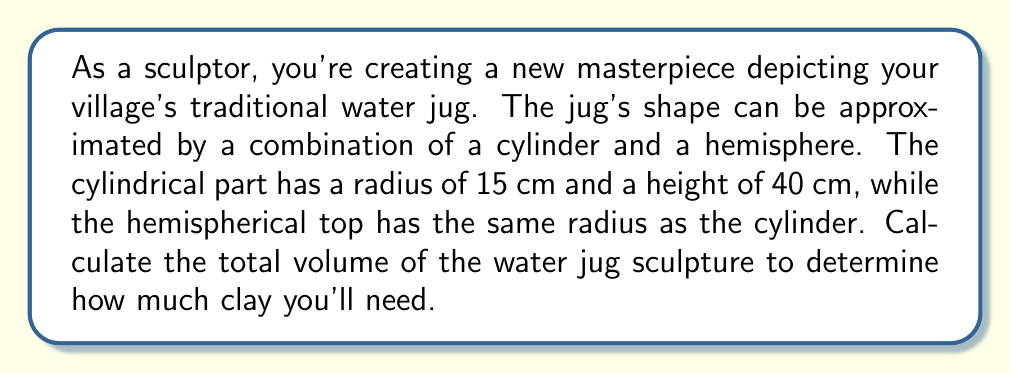Could you help me with this problem? To solve this problem, we need to calculate the volumes of the cylinder and hemisphere separately, then add them together.

1. Volume of the cylinder:
   The formula for the volume of a cylinder is $V_{cylinder} = \pi r^2 h$
   Where $r$ is the radius and $h$ is the height.
   
   $$V_{cylinder} = \pi (15\text{ cm})^2 (40\text{ cm}) = 28,274.33\text{ cm}^3$$

2. Volume of the hemisphere:
   The formula for the volume of a hemisphere is $V_{hemisphere} = \frac{2}{3}\pi r^3$
   
   $$V_{hemisphere} = \frac{2}{3}\pi (15\text{ cm})^3 = 7,068.58\text{ cm}^3$$

3. Total volume:
   Add the volumes of the cylinder and hemisphere:
   
   $$V_{total} = V_{cylinder} + V_{hemisphere}$$
   $$V_{total} = 28,274.33\text{ cm}^3 + 7,068.58\text{ cm}^3 = 35,342.91\text{ cm}^3$$

[asy]
import three;

size(200);
currentprojection=perspective(6,3,2);

// Draw cylinder
draw(surface(cylinder((0,0,0),15,40)),paleblue);

// Draw hemisphere
draw(surface(hemisphere((0,0,40),15)),paleblue);

// Draw axes
draw((0,0,0)--(20,0,0),arrow=Arrow3);
draw((0,0,0)--(0,20,0),arrow=Arrow3);
draw((0,0,0)--(0,0,50),arrow=Arrow3);

label("x",(20,0,0),W);
label("y",(0,20,0),N);
label("z",(0,0,50),E);
[/asy]
Answer: The total volume of the water jug sculpture is approximately $35,342.91\text{ cm}^3$. 